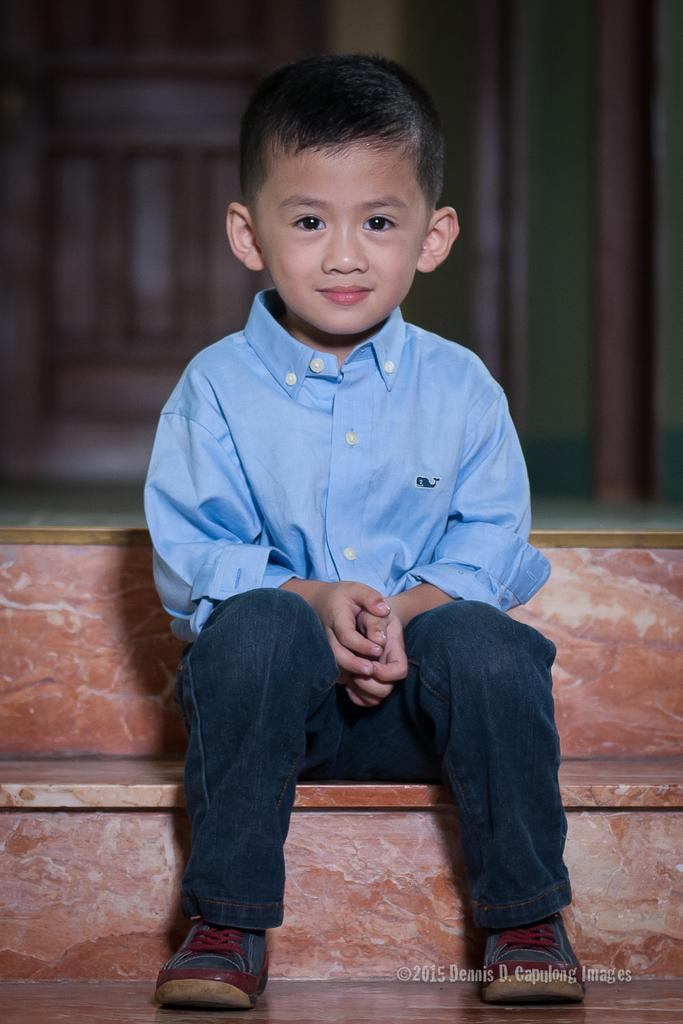Who is the main subject in the image? There is a boy in the image. What is the boy doing in the image? The boy is sitting on the stairs. What is the boy's facial expression in the image? The boy is smiling. What can be seen at the bottom of the image? There is some text at the bottom of the image. How would you describe the background of the image? The background of the image is blurred. What type of mass is the boy attending in the image? There is no indication of a mass or any religious gathering in the image; it simply shows a boy sitting on the stairs and smiling. 